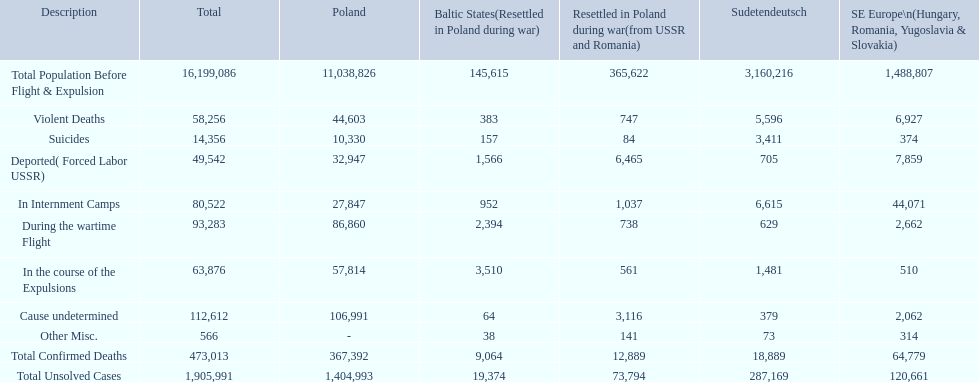How many deaths did the baltic states have in each category? 145,615, 383, 157, 1,566, 952, 2,394, 3,510, 64, 38, 9,064, 19,374. How many cause undetermined deaths did baltic states have? 64. How many other miscellaneous deaths did baltic states have? 38. Which is higher in deaths, cause undetermined or other miscellaneous? Cause undetermined. 